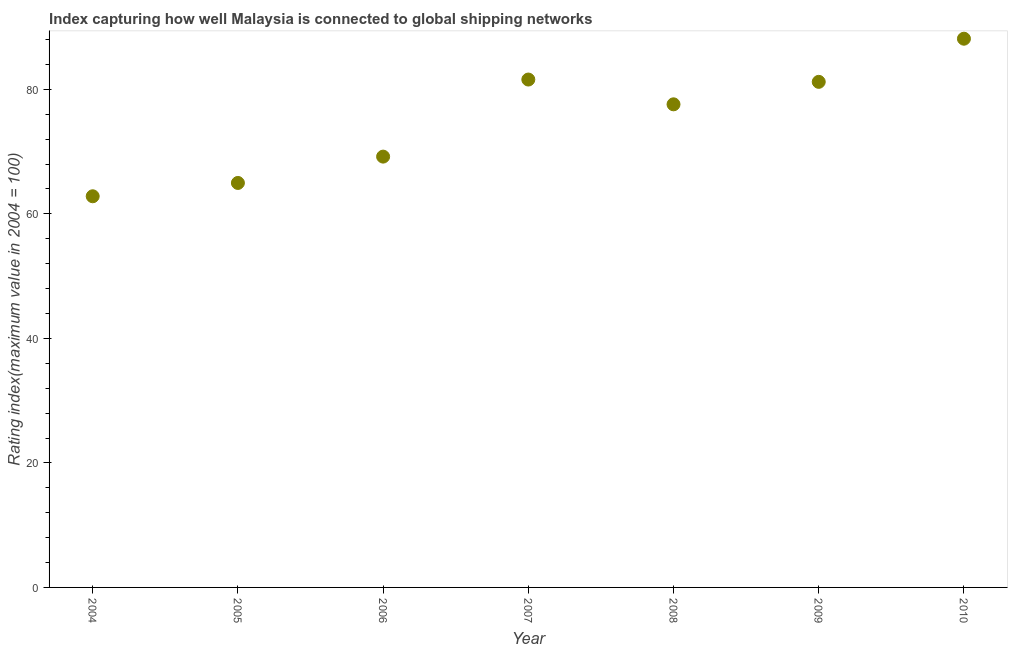What is the liner shipping connectivity index in 2006?
Ensure brevity in your answer.  69.2. Across all years, what is the maximum liner shipping connectivity index?
Provide a succinct answer. 88.14. Across all years, what is the minimum liner shipping connectivity index?
Make the answer very short. 62.83. In which year was the liner shipping connectivity index maximum?
Provide a succinct answer. 2010. In which year was the liner shipping connectivity index minimum?
Your answer should be compact. 2004. What is the sum of the liner shipping connectivity index?
Offer a terse response. 525.53. What is the difference between the liner shipping connectivity index in 2004 and 2010?
Ensure brevity in your answer.  -25.31. What is the average liner shipping connectivity index per year?
Provide a short and direct response. 75.08. What is the median liner shipping connectivity index?
Make the answer very short. 77.6. What is the ratio of the liner shipping connectivity index in 2004 to that in 2005?
Give a very brief answer. 0.97. Is the liner shipping connectivity index in 2008 less than that in 2010?
Offer a very short reply. Yes. Is the difference between the liner shipping connectivity index in 2006 and 2007 greater than the difference between any two years?
Your answer should be compact. No. What is the difference between the highest and the second highest liner shipping connectivity index?
Your answer should be compact. 6.56. What is the difference between the highest and the lowest liner shipping connectivity index?
Your answer should be compact. 25.31. Does the liner shipping connectivity index monotonically increase over the years?
Keep it short and to the point. No. What is the difference between two consecutive major ticks on the Y-axis?
Your answer should be very brief. 20. Are the values on the major ticks of Y-axis written in scientific E-notation?
Your response must be concise. No. Does the graph contain grids?
Make the answer very short. No. What is the title of the graph?
Offer a terse response. Index capturing how well Malaysia is connected to global shipping networks. What is the label or title of the X-axis?
Provide a short and direct response. Year. What is the label or title of the Y-axis?
Give a very brief answer. Rating index(maximum value in 2004 = 100). What is the Rating index(maximum value in 2004 = 100) in 2004?
Offer a very short reply. 62.83. What is the Rating index(maximum value in 2004 = 100) in 2005?
Your answer should be compact. 64.97. What is the Rating index(maximum value in 2004 = 100) in 2006?
Your answer should be compact. 69.2. What is the Rating index(maximum value in 2004 = 100) in 2007?
Provide a short and direct response. 81.58. What is the Rating index(maximum value in 2004 = 100) in 2008?
Provide a succinct answer. 77.6. What is the Rating index(maximum value in 2004 = 100) in 2009?
Make the answer very short. 81.21. What is the Rating index(maximum value in 2004 = 100) in 2010?
Provide a short and direct response. 88.14. What is the difference between the Rating index(maximum value in 2004 = 100) in 2004 and 2005?
Your answer should be very brief. -2.14. What is the difference between the Rating index(maximum value in 2004 = 100) in 2004 and 2006?
Offer a terse response. -6.37. What is the difference between the Rating index(maximum value in 2004 = 100) in 2004 and 2007?
Offer a terse response. -18.75. What is the difference between the Rating index(maximum value in 2004 = 100) in 2004 and 2008?
Your response must be concise. -14.77. What is the difference between the Rating index(maximum value in 2004 = 100) in 2004 and 2009?
Your response must be concise. -18.38. What is the difference between the Rating index(maximum value in 2004 = 100) in 2004 and 2010?
Offer a terse response. -25.31. What is the difference between the Rating index(maximum value in 2004 = 100) in 2005 and 2006?
Keep it short and to the point. -4.23. What is the difference between the Rating index(maximum value in 2004 = 100) in 2005 and 2007?
Ensure brevity in your answer.  -16.61. What is the difference between the Rating index(maximum value in 2004 = 100) in 2005 and 2008?
Ensure brevity in your answer.  -12.63. What is the difference between the Rating index(maximum value in 2004 = 100) in 2005 and 2009?
Your response must be concise. -16.24. What is the difference between the Rating index(maximum value in 2004 = 100) in 2005 and 2010?
Give a very brief answer. -23.17. What is the difference between the Rating index(maximum value in 2004 = 100) in 2006 and 2007?
Offer a terse response. -12.38. What is the difference between the Rating index(maximum value in 2004 = 100) in 2006 and 2009?
Give a very brief answer. -12.01. What is the difference between the Rating index(maximum value in 2004 = 100) in 2006 and 2010?
Provide a short and direct response. -18.94. What is the difference between the Rating index(maximum value in 2004 = 100) in 2007 and 2008?
Your answer should be very brief. 3.98. What is the difference between the Rating index(maximum value in 2004 = 100) in 2007 and 2009?
Give a very brief answer. 0.37. What is the difference between the Rating index(maximum value in 2004 = 100) in 2007 and 2010?
Your response must be concise. -6.56. What is the difference between the Rating index(maximum value in 2004 = 100) in 2008 and 2009?
Ensure brevity in your answer.  -3.61. What is the difference between the Rating index(maximum value in 2004 = 100) in 2008 and 2010?
Give a very brief answer. -10.54. What is the difference between the Rating index(maximum value in 2004 = 100) in 2009 and 2010?
Offer a terse response. -6.93. What is the ratio of the Rating index(maximum value in 2004 = 100) in 2004 to that in 2006?
Your answer should be very brief. 0.91. What is the ratio of the Rating index(maximum value in 2004 = 100) in 2004 to that in 2007?
Provide a short and direct response. 0.77. What is the ratio of the Rating index(maximum value in 2004 = 100) in 2004 to that in 2008?
Give a very brief answer. 0.81. What is the ratio of the Rating index(maximum value in 2004 = 100) in 2004 to that in 2009?
Your answer should be very brief. 0.77. What is the ratio of the Rating index(maximum value in 2004 = 100) in 2004 to that in 2010?
Your answer should be very brief. 0.71. What is the ratio of the Rating index(maximum value in 2004 = 100) in 2005 to that in 2006?
Ensure brevity in your answer.  0.94. What is the ratio of the Rating index(maximum value in 2004 = 100) in 2005 to that in 2007?
Your answer should be compact. 0.8. What is the ratio of the Rating index(maximum value in 2004 = 100) in 2005 to that in 2008?
Make the answer very short. 0.84. What is the ratio of the Rating index(maximum value in 2004 = 100) in 2005 to that in 2009?
Offer a very short reply. 0.8. What is the ratio of the Rating index(maximum value in 2004 = 100) in 2005 to that in 2010?
Ensure brevity in your answer.  0.74. What is the ratio of the Rating index(maximum value in 2004 = 100) in 2006 to that in 2007?
Offer a very short reply. 0.85. What is the ratio of the Rating index(maximum value in 2004 = 100) in 2006 to that in 2008?
Make the answer very short. 0.89. What is the ratio of the Rating index(maximum value in 2004 = 100) in 2006 to that in 2009?
Your response must be concise. 0.85. What is the ratio of the Rating index(maximum value in 2004 = 100) in 2006 to that in 2010?
Make the answer very short. 0.79. What is the ratio of the Rating index(maximum value in 2004 = 100) in 2007 to that in 2008?
Your answer should be very brief. 1.05. What is the ratio of the Rating index(maximum value in 2004 = 100) in 2007 to that in 2010?
Your answer should be compact. 0.93. What is the ratio of the Rating index(maximum value in 2004 = 100) in 2008 to that in 2009?
Your response must be concise. 0.96. What is the ratio of the Rating index(maximum value in 2004 = 100) in 2008 to that in 2010?
Ensure brevity in your answer.  0.88. What is the ratio of the Rating index(maximum value in 2004 = 100) in 2009 to that in 2010?
Your answer should be very brief. 0.92. 